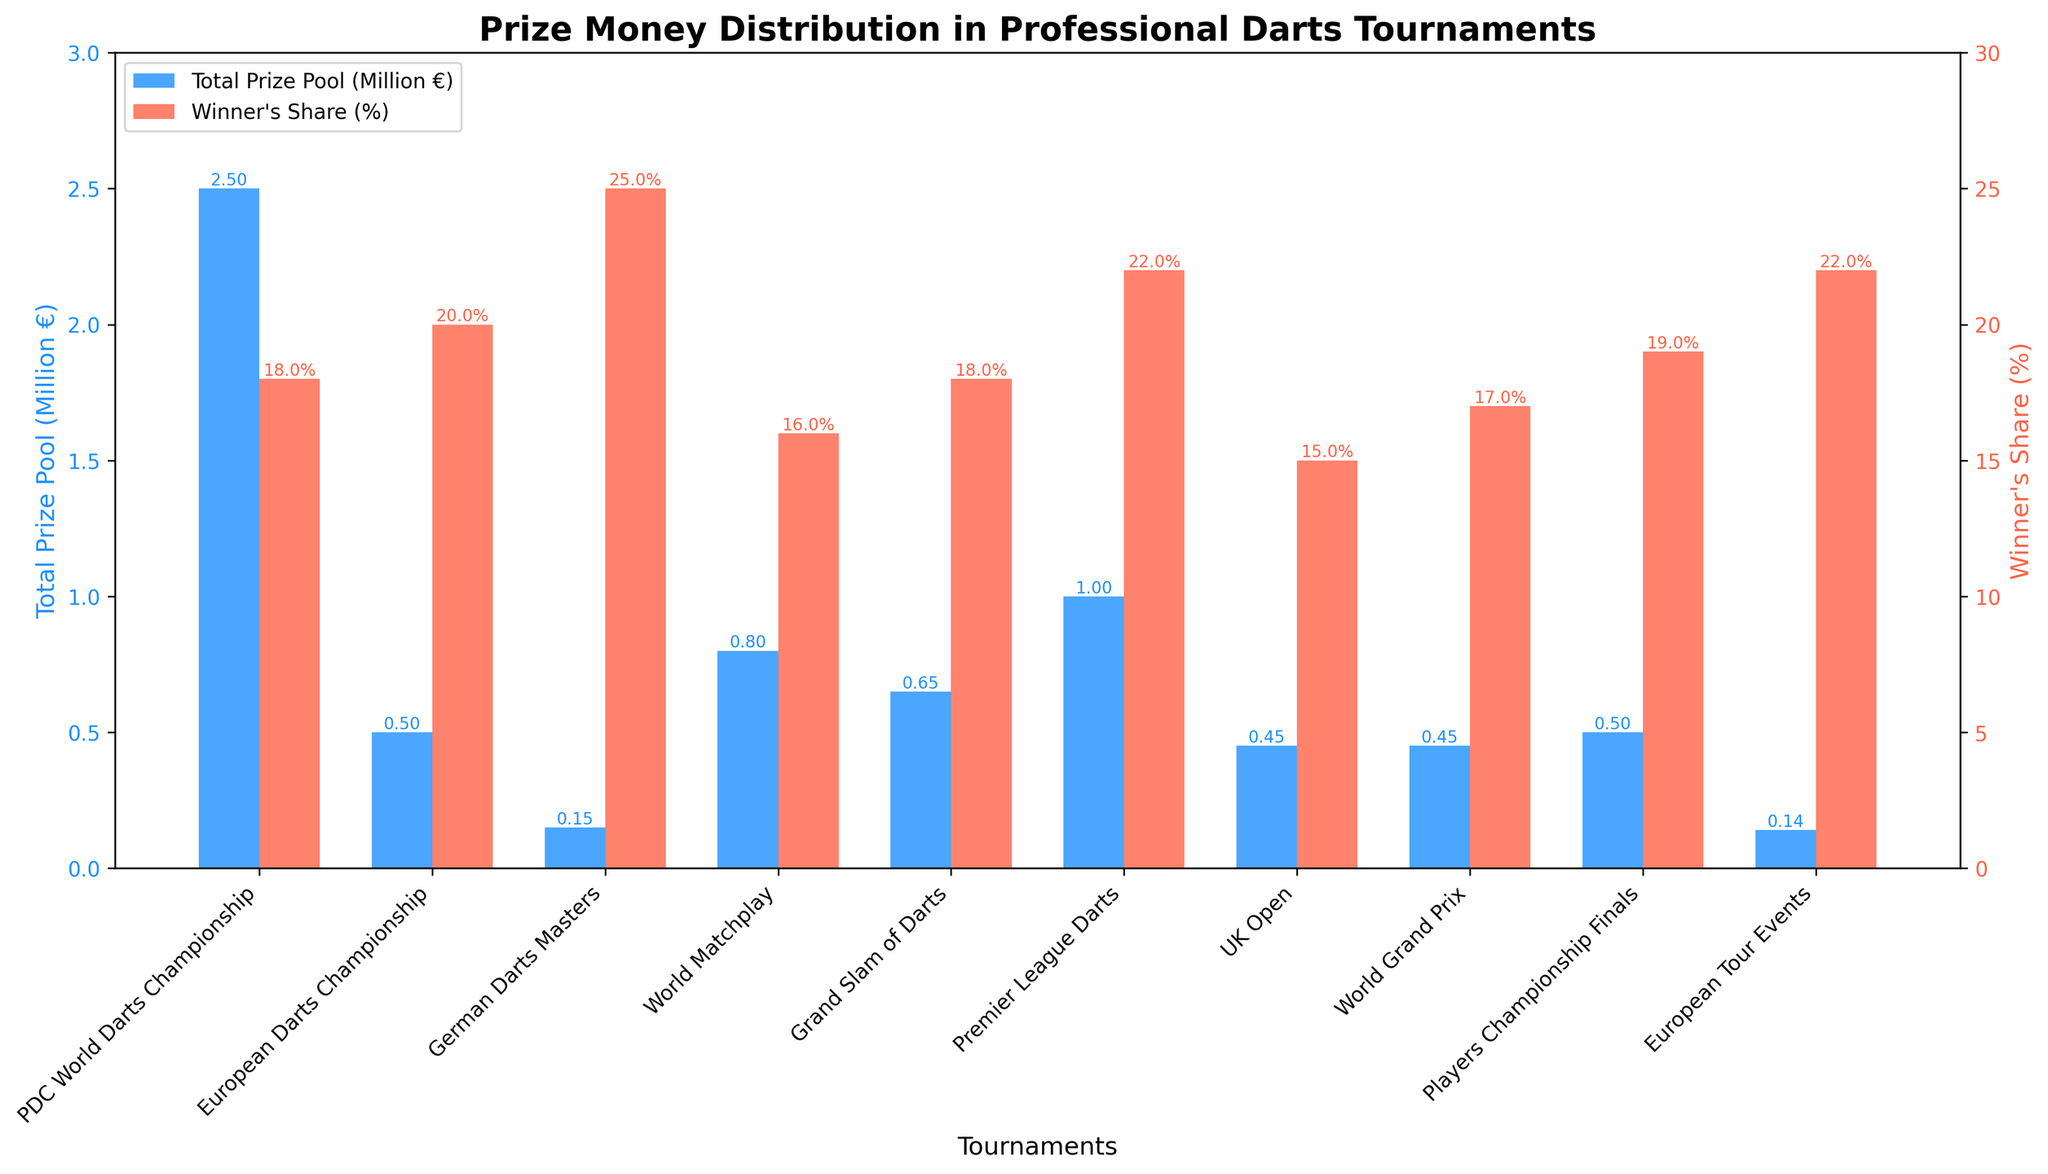What tournament has the highest total prize pool? The bar representing the "PDC World Darts Championship" is the tallest in the blue color, indicating it has the highest total prize pool.
Answer: PDC World Darts Championship What percentage does the winner of the German Darts Masters receive? The red bar for the "German Darts Masters" has a height corresponding closely to 25%, the value can be read from the y-axis for winner's share on the right.
Answer: 25% Which tournament offers a greater winner's share, the Premier League Darts or the Grand Slam of Darts? Compare the heights of the red bars for both tournaments. Premier League Darts has a taller red bar compared to Grand Slam of Darts.
Answer: Premier League Darts What is the total prize pool difference between the World Matchplay and the UK Open? The blue bar for the World Matchplay shows approximately 0.8M and for the UK Open around 0.45M. The difference is 0.8M - 0.45M = 0.35M.
Answer: 0.35M By how much does the winner's share in the European Tour Events exceed that of the Players Championship Finals? The red bar for the "European Tour Events" shows 22% while the "Players Championship Finals" shows 19%. The difference is 22% - 19% = 3%.
Answer: 3% Which tournament has the smallest total prize pool? The shortest blue bar represents the "German Darts Masters" indicating the smallest total prize pool.
Answer: German Darts Masters What is the average total prize pool of the top three tournaments with the highest prize pools? The top three tournaments are "PDC World Darts Championship" (2.5M), "Premier League Darts" (1M), and "World Matchplay" (0.8M). The average is (2.5M + 1M + 0.8M) / 3 = 1.433M.
Answer: 1.433M What is the combined winner's share percentage for the top two tournaments in terms of total prize pool? The top two tournaments by prize pool are "PDC World Darts Championship" (18%) and "Premier League Darts" (22%). The combined percentage is 18% + 22% = 40%.
Answer: 40% Which tournament between the World Grand Prix and the UK Open gives a higher percentage to the semi-finalists? By comparing the semi-finalists' share percentages, the "World Grand Prix" gives 4.25% while the "UK Open" gives 3.75%.
Answer: World Grand Prix 